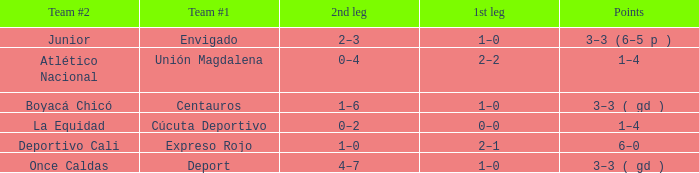What is the team #2 with Deport as team #1? Once Caldas. 